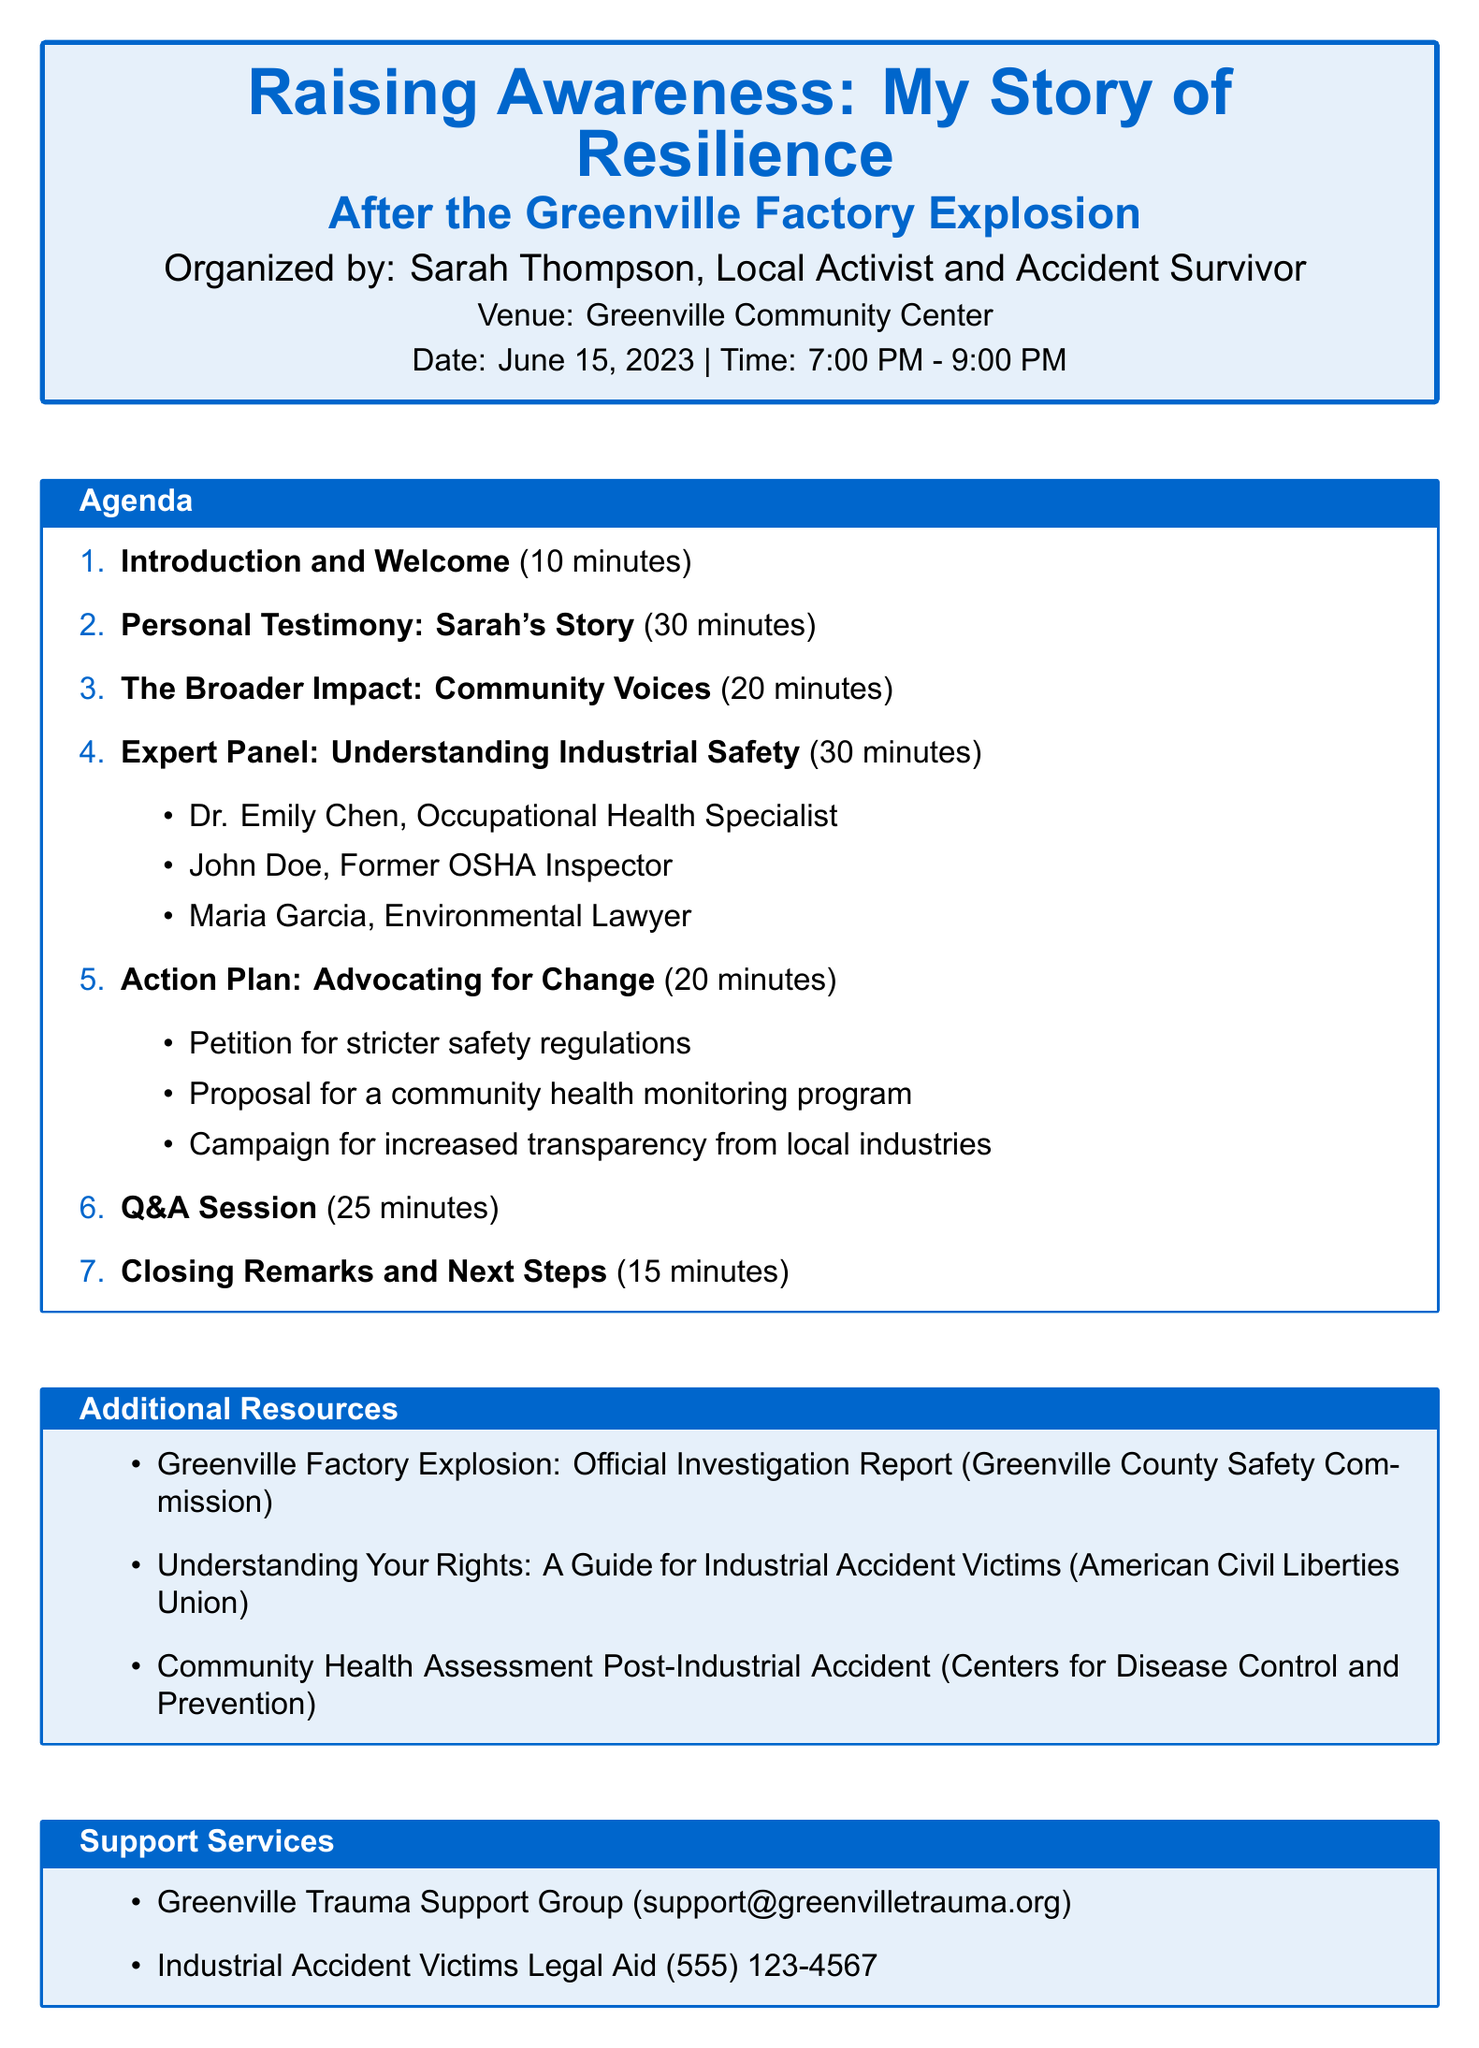What is the title of the meeting? The title of the meeting is provided prominently at the top of the document, featuring the theme of resilience and a specific incident.
Answer: Raising Awareness: My Story of Resilience After the Greenville Factory Explosion Who is organizing the meeting? The organizer's name is mentioned alongside their role as a local activist and survivor of the accident.
Answer: Sarah Thompson What is the date of the meeting? The date of the meeting is listed below the venue and organizer details.
Answer: June 15, 2023 How long is the personal testimony session? The duration of the personal testimony session is indicated alongside its title in the agenda.
Answer: 30 minutes Who is on the expert panel? The names of the expert panelists are listed under the relevant agenda item and include professionals from different fields.
Answer: Dr. Emily Chen, John Doe, Maria Garcia What is one point in the action plan? Specific action points are outlined in the agenda, indicating the steps to be taken for advocacy.
Answer: Petition for stricter safety regulations How long is the Q&A session? The duration for the Q&A session is stated in the agenda section, indicating the time allocated for this interaction.
Answer: 25 minutes Where is the venue for the meeting? The venue for the meeting is provided shortly after the organizer's details in the document.
Answer: Greenville Community Center What type of support service is offered? The support services listed include organizations providing assistance to those affected by the accident.
Answer: Greenville Trauma Support Group 